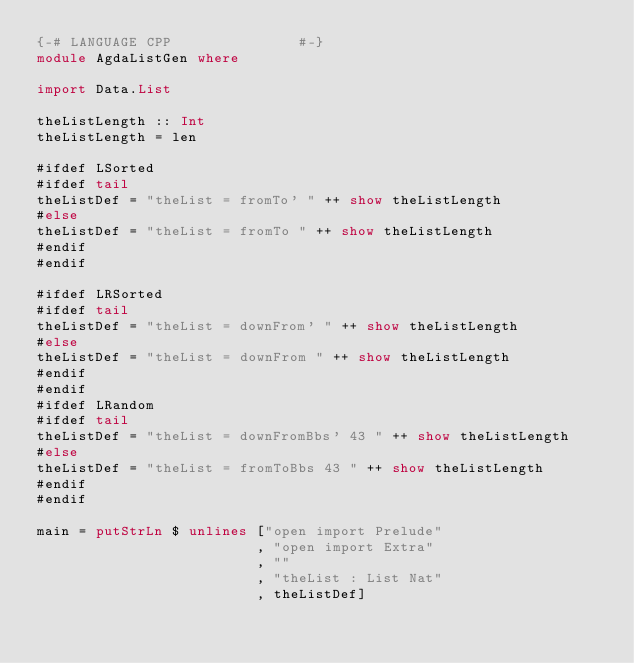Convert code to text. <code><loc_0><loc_0><loc_500><loc_500><_Haskell_>{-# LANGUAGE CPP               #-}
module AgdaListGen where

import Data.List

theListLength :: Int
theListLength = len

#ifdef LSorted
#ifdef tail
theListDef = "theList = fromTo' " ++ show theListLength
#else
theListDef = "theList = fromTo " ++ show theListLength
#endif
#endif

#ifdef LRSorted
#ifdef tail
theListDef = "theList = downFrom' " ++ show theListLength
#else
theListDef = "theList = downFrom " ++ show theListLength
#endif
#endif
#ifdef LRandom
#ifdef tail
theListDef = "theList = downFromBbs' 43 " ++ show theListLength
#else
theListDef = "theList = fromToBbs 43 " ++ show theListLength
#endif
#endif

main = putStrLn $ unlines ["open import Prelude"
                          , "open import Extra"
                          , ""
                          , "theList : List Nat"
                          , theListDef]

</code> 